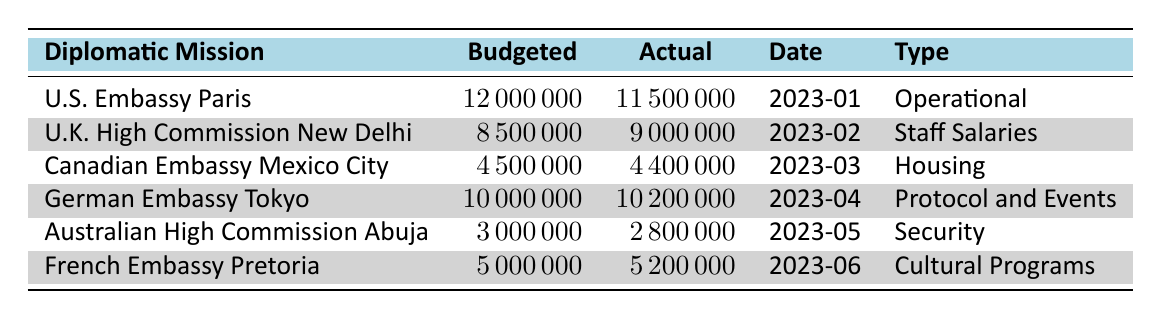What is the budgeted expenditure for the U.K. High Commission New Delhi? The budgeted expenditure for the U.K. High Commission New Delhi is directly listed in the table, which shows a value of 8500000.
Answer: 8500000 How much did the Canadian Embassy Mexico City actually spend? The actual expenditure for the Canadian Embassy Mexico City is found in the table, where it states the value as 4400000.
Answer: 4400000 Which diplomatic mission had the highest actual expenditure? To find out which mission had the highest actual expenditure, I will compare the actual expenditure values across all entries. The German Embassy Tokyo spent 10200000, which is the highest among the listed missions.
Answer: German Embassy Tokyo Was the actual expenditure for the French Embassy Pretoria within the budget? To determine this, I will compare the actual expenditure, which is 5200000, with the budgeted expenditure of 5000000 for the French Embassy Pretoria. Since 5200000 is greater than 5000000, the actual expenditure was not within the budget.
Answer: No What is the total budgeted expenditure for all diplomatic missions combined? I will sum the budgeted expenditures for all missions listed: 12000000 + 8500000 + 4500000 + 10000000 + 3000000 + 5000000 = 40500000.
Answer: 40500000 Did the U.S. Embassy Paris spend less than budgeted? Comparing the values, the U.S. Embassy Paris had a budgeted expenditure of 12000000 and an actual expenditure of 11500000. Since 11500000 is less than 12000000, it confirms that they spent less than budgeted.
Answer: Yes What is the difference between the budgeted and actual expenditures for the German Embassy Tokyo? The budgeted expenditure is 10000000 and the actual expenditure is 10200000. The difference is 10200000 - 10000000 = 200000.
Answer: 200000 Which expenditure type had the highest budgeted expenditure? I will compare the budgeted expenditures for the listed expenditure types. The U.S. Embassy Paris (Operational) had the highest budgeted expenditure at 12000000.
Answer: Operational What is the average actual expenditure of all missions listed? To find the average, first, I’ll total the actual expenditures: 11500000 + 9000000 + 4400000 + 10200000 + 2800000 + 5200000 = 40000000. There are 6 missions, so the average is 40000000 / 6 = 6666666.67.
Answer: 6666666.67 